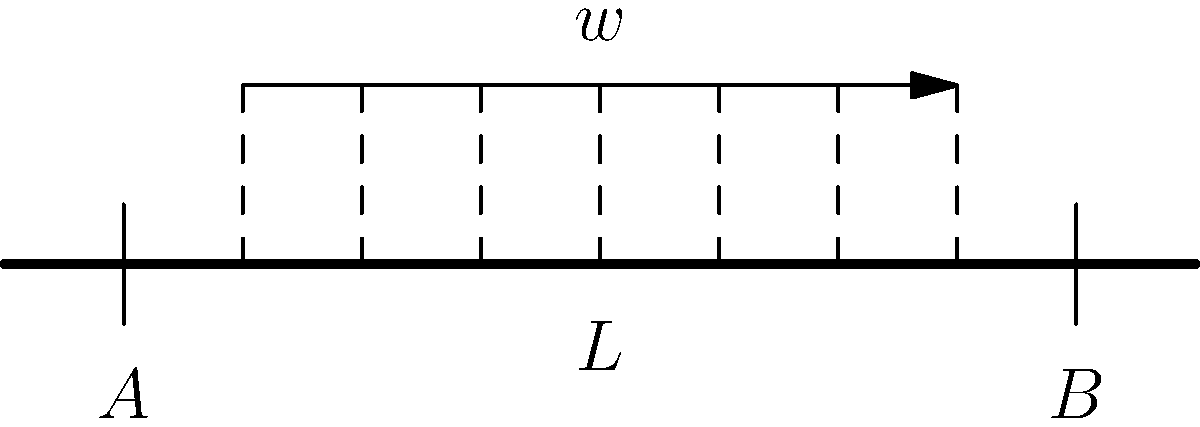In the context of stress management for esports players, consider a simply supported beam of length $L$ subjected to a uniformly distributed load $w$. How does the maximum bending moment in the beam relate to the load and span? Express your answer in terms of $w$ and $L$. To find the maximum bending moment in a simply supported beam with a uniformly distributed load, we can follow these steps:

1. Identify the load and support conditions:
   - Uniformly distributed load $w$ over the entire span
   - Simply supported at both ends (pinned at A and roller at B)

2. Calculate the reactions at the supports:
   - Due to symmetry, each support reaction is half the total load
   - $R_A = R_B = \frac{wL}{2}$

3. Determine the bending moment equation:
   - At any point $x$ from the left support:
   $M(x) = R_A \cdot x - w \cdot x \cdot \frac{x}{2}$
   $M(x) = \frac{wL}{2} \cdot x - \frac{wx^2}{2}$

4. Find the location of maximum bending moment:
   - Occurs at the midspan due to symmetry
   - $x = \frac{L}{2}$

5. Calculate the maximum bending moment:
   $M_{max} = \frac{wL}{2} \cdot \frac{L}{2} - \frac{w(\frac{L}{2})^2}{2}$
   $M_{max} = \frac{wL^2}{4} - \frac{wL^2}{8} = \frac{wL^2}{8}$

Thus, the maximum bending moment is $\frac{wL^2}{8}$.

This relationship between load, span, and maximum bending moment can be metaphorically applied to stress management in esports, where the "load" represents mental pressure and the "span" represents a player's resilience over time.
Answer: $\frac{wL^2}{8}$ 